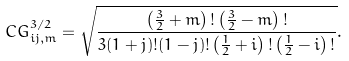Convert formula to latex. <formula><loc_0><loc_0><loc_500><loc_500>C G _ { i j , m } ^ { 3 / 2 } = \sqrt { \frac { \left ( \frac { 3 } { 2 } + m \right ) ! \left ( \frac { 3 } { 2 } - m \right ) ! } { 3 ( 1 + j ) ! ( 1 - j ) ! \left ( \frac { 1 } { 2 } + i \right ) ! \left ( \frac { 1 } { 2 } - i \right ) ! } } .</formula> 